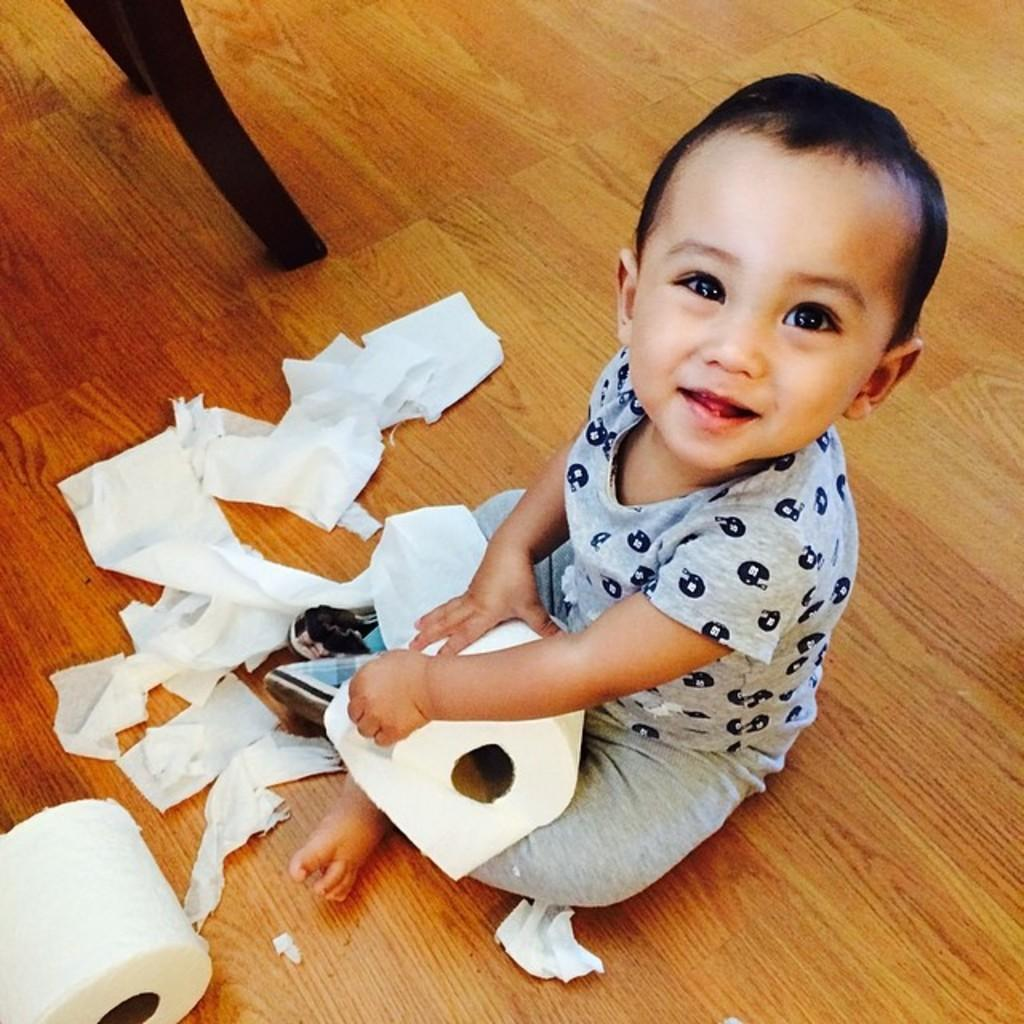Who is the main subject in the image? There is a boy in the image. What is the boy doing in the image? The boy is sitting on the floor. What is the boy holding in his hands? The boy is holding a tissue roll in his hands. Can you describe the tissue-related items in the image? There are tissue papers and a tissue roll in the image. What else can be seen on the floor in the image? The legs of a chair are visible on the floor. What is the weather like outside during the day in the image? The provided facts do not mention any information about the weather or time of day, so it cannot be determined from the image. 